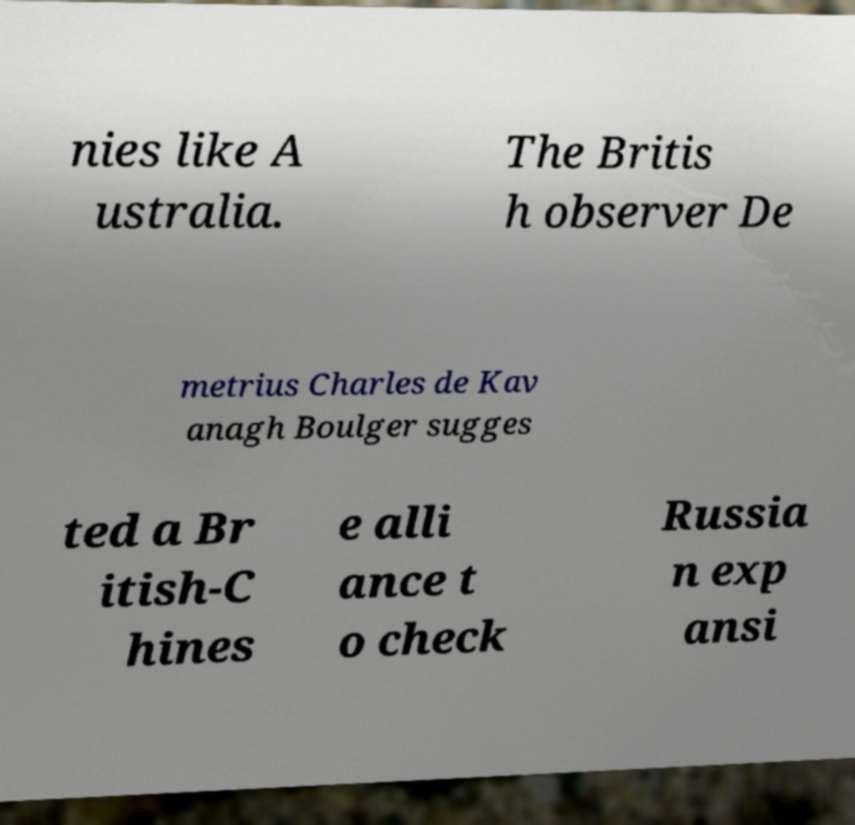I need the written content from this picture converted into text. Can you do that? nies like A ustralia. The Britis h observer De metrius Charles de Kav anagh Boulger sugges ted a Br itish-C hines e alli ance t o check Russia n exp ansi 